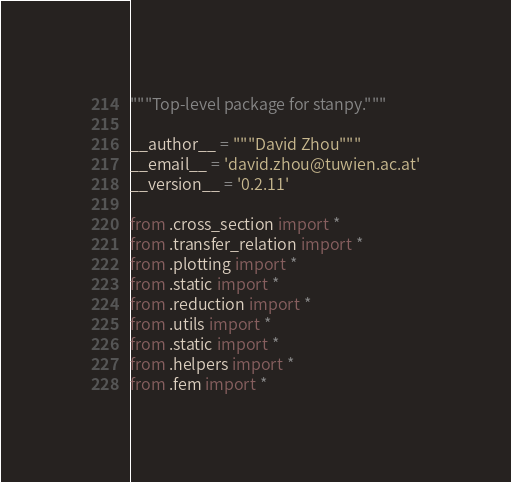<code> <loc_0><loc_0><loc_500><loc_500><_Python_>"""Top-level package for stanpy."""

__author__ = """David Zhou"""
__email__ = 'david.zhou@tuwien.ac.at'
__version__ = '0.2.11'

from .cross_section import *
from .transfer_relation import *
from .plotting import *
from .static import *
from .reduction import *
from .utils import *
from .static import *
from .helpers import *
from .fem import *
</code> 